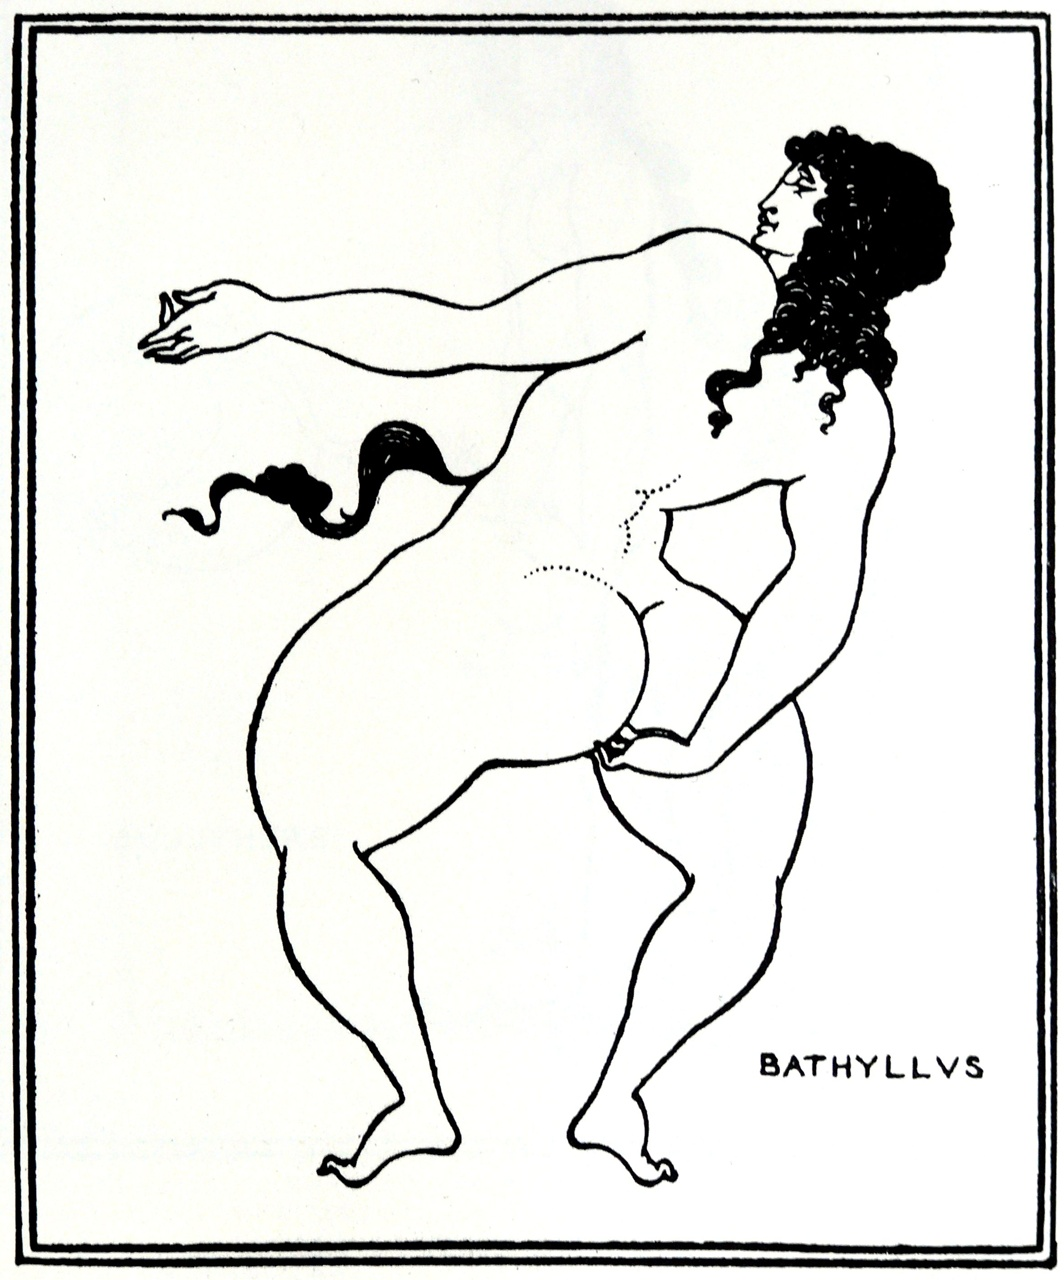What is the significance of the stance adopted by Bathyllys in this artwork? The stance of Bathyllys, balanced and poised, is indicative of a pose that might be seen in ancient dances or theatrical performances. Known as the 'Dancing Krousis,', this pose suggests movement and grace, typical in depictions of performers and athletes from ancient Greek culture, emphasizing agility and artistic expression. How common is such a depiction in ancient artworks? Such depictions are relatively common in Greek and Roman art, particularly on pottery and frescoes. They often depicted figures in poses of action or drama, reflecting the societies' admiration for physical prowess and theatricality. These artworks served both decorative and narrative purposes, telling stories of gods, heroes, and everyday individuals. 